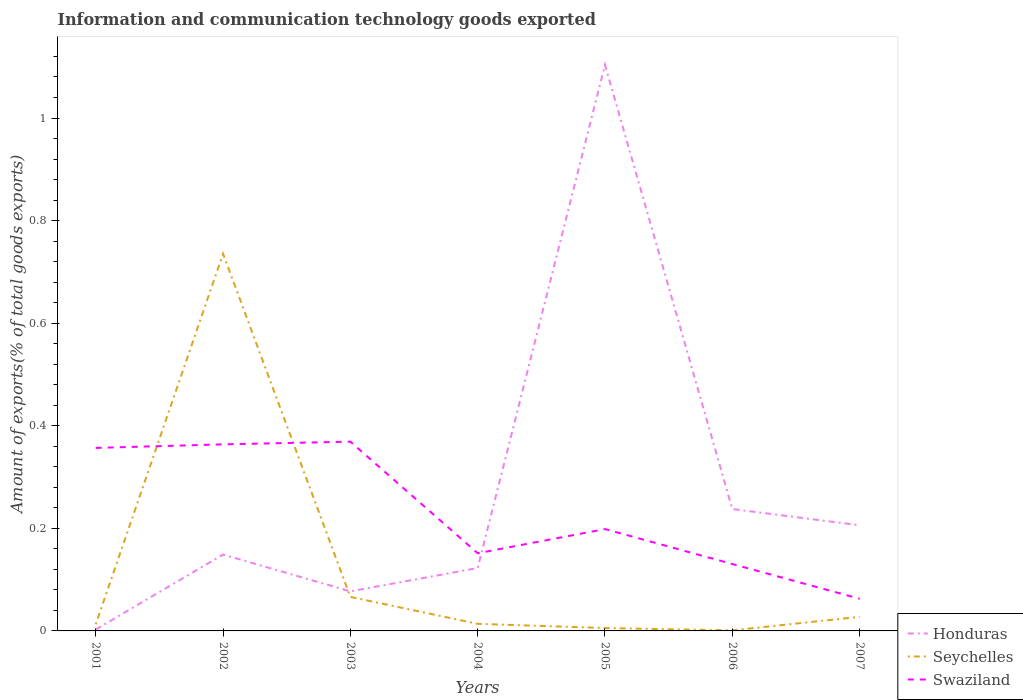How many different coloured lines are there?
Provide a succinct answer. 3. Does the line corresponding to Seychelles intersect with the line corresponding to Swaziland?
Offer a terse response. Yes. Is the number of lines equal to the number of legend labels?
Keep it short and to the point. Yes. Across all years, what is the maximum amount of goods exported in Swaziland?
Provide a succinct answer. 0.06. In which year was the amount of goods exported in Swaziland maximum?
Offer a very short reply. 2007. What is the total amount of goods exported in Swaziland in the graph?
Provide a short and direct response. 0.29. What is the difference between the highest and the second highest amount of goods exported in Seychelles?
Your answer should be compact. 0.73. What is the difference between the highest and the lowest amount of goods exported in Swaziland?
Your response must be concise. 3. Is the amount of goods exported in Honduras strictly greater than the amount of goods exported in Seychelles over the years?
Your answer should be compact. No. How many lines are there?
Provide a succinct answer. 3. How many years are there in the graph?
Ensure brevity in your answer.  7. Does the graph contain any zero values?
Your answer should be very brief. No. Does the graph contain grids?
Offer a very short reply. No. Where does the legend appear in the graph?
Make the answer very short. Bottom right. How are the legend labels stacked?
Your answer should be compact. Vertical. What is the title of the graph?
Your response must be concise. Information and communication technology goods exported. What is the label or title of the X-axis?
Your answer should be compact. Years. What is the label or title of the Y-axis?
Make the answer very short. Amount of exports(% of total goods exports). What is the Amount of exports(% of total goods exports) in Honduras in 2001?
Your answer should be compact. 0. What is the Amount of exports(% of total goods exports) in Seychelles in 2001?
Provide a short and direct response. 0.01. What is the Amount of exports(% of total goods exports) in Swaziland in 2001?
Provide a succinct answer. 0.36. What is the Amount of exports(% of total goods exports) in Honduras in 2002?
Keep it short and to the point. 0.15. What is the Amount of exports(% of total goods exports) in Seychelles in 2002?
Offer a very short reply. 0.74. What is the Amount of exports(% of total goods exports) of Swaziland in 2002?
Make the answer very short. 0.36. What is the Amount of exports(% of total goods exports) of Honduras in 2003?
Your answer should be compact. 0.08. What is the Amount of exports(% of total goods exports) in Seychelles in 2003?
Make the answer very short. 0.07. What is the Amount of exports(% of total goods exports) of Swaziland in 2003?
Your answer should be very brief. 0.37. What is the Amount of exports(% of total goods exports) in Honduras in 2004?
Offer a very short reply. 0.12. What is the Amount of exports(% of total goods exports) of Seychelles in 2004?
Offer a very short reply. 0.01. What is the Amount of exports(% of total goods exports) in Swaziland in 2004?
Your answer should be compact. 0.15. What is the Amount of exports(% of total goods exports) of Honduras in 2005?
Offer a terse response. 1.1. What is the Amount of exports(% of total goods exports) of Seychelles in 2005?
Your answer should be compact. 0.01. What is the Amount of exports(% of total goods exports) of Swaziland in 2005?
Give a very brief answer. 0.2. What is the Amount of exports(% of total goods exports) in Honduras in 2006?
Offer a terse response. 0.24. What is the Amount of exports(% of total goods exports) in Seychelles in 2006?
Make the answer very short. 0. What is the Amount of exports(% of total goods exports) of Swaziland in 2006?
Offer a very short reply. 0.13. What is the Amount of exports(% of total goods exports) of Honduras in 2007?
Offer a terse response. 0.21. What is the Amount of exports(% of total goods exports) of Seychelles in 2007?
Offer a terse response. 0.03. What is the Amount of exports(% of total goods exports) of Swaziland in 2007?
Offer a terse response. 0.06. Across all years, what is the maximum Amount of exports(% of total goods exports) in Honduras?
Keep it short and to the point. 1.1. Across all years, what is the maximum Amount of exports(% of total goods exports) of Seychelles?
Your answer should be compact. 0.74. Across all years, what is the maximum Amount of exports(% of total goods exports) of Swaziland?
Ensure brevity in your answer.  0.37. Across all years, what is the minimum Amount of exports(% of total goods exports) in Honduras?
Ensure brevity in your answer.  0. Across all years, what is the minimum Amount of exports(% of total goods exports) of Seychelles?
Ensure brevity in your answer.  0. Across all years, what is the minimum Amount of exports(% of total goods exports) of Swaziland?
Keep it short and to the point. 0.06. What is the total Amount of exports(% of total goods exports) in Honduras in the graph?
Your answer should be very brief. 1.9. What is the total Amount of exports(% of total goods exports) of Seychelles in the graph?
Your answer should be very brief. 0.86. What is the total Amount of exports(% of total goods exports) of Swaziland in the graph?
Provide a succinct answer. 1.63. What is the difference between the Amount of exports(% of total goods exports) in Honduras in 2001 and that in 2002?
Offer a terse response. -0.15. What is the difference between the Amount of exports(% of total goods exports) in Seychelles in 2001 and that in 2002?
Ensure brevity in your answer.  -0.72. What is the difference between the Amount of exports(% of total goods exports) of Swaziland in 2001 and that in 2002?
Keep it short and to the point. -0.01. What is the difference between the Amount of exports(% of total goods exports) in Honduras in 2001 and that in 2003?
Give a very brief answer. -0.07. What is the difference between the Amount of exports(% of total goods exports) of Seychelles in 2001 and that in 2003?
Ensure brevity in your answer.  -0.05. What is the difference between the Amount of exports(% of total goods exports) in Swaziland in 2001 and that in 2003?
Your answer should be very brief. -0.01. What is the difference between the Amount of exports(% of total goods exports) of Honduras in 2001 and that in 2004?
Make the answer very short. -0.12. What is the difference between the Amount of exports(% of total goods exports) in Seychelles in 2001 and that in 2004?
Offer a terse response. -0. What is the difference between the Amount of exports(% of total goods exports) of Swaziland in 2001 and that in 2004?
Offer a very short reply. 0.21. What is the difference between the Amount of exports(% of total goods exports) in Honduras in 2001 and that in 2005?
Keep it short and to the point. -1.1. What is the difference between the Amount of exports(% of total goods exports) of Seychelles in 2001 and that in 2005?
Your answer should be compact. 0.01. What is the difference between the Amount of exports(% of total goods exports) of Swaziland in 2001 and that in 2005?
Your answer should be very brief. 0.16. What is the difference between the Amount of exports(% of total goods exports) in Honduras in 2001 and that in 2006?
Provide a succinct answer. -0.23. What is the difference between the Amount of exports(% of total goods exports) of Seychelles in 2001 and that in 2006?
Provide a short and direct response. 0.01. What is the difference between the Amount of exports(% of total goods exports) of Swaziland in 2001 and that in 2006?
Your answer should be compact. 0.23. What is the difference between the Amount of exports(% of total goods exports) in Honduras in 2001 and that in 2007?
Offer a very short reply. -0.2. What is the difference between the Amount of exports(% of total goods exports) of Seychelles in 2001 and that in 2007?
Your answer should be compact. -0.01. What is the difference between the Amount of exports(% of total goods exports) of Swaziland in 2001 and that in 2007?
Your answer should be very brief. 0.29. What is the difference between the Amount of exports(% of total goods exports) in Honduras in 2002 and that in 2003?
Offer a terse response. 0.07. What is the difference between the Amount of exports(% of total goods exports) of Seychelles in 2002 and that in 2003?
Provide a succinct answer. 0.67. What is the difference between the Amount of exports(% of total goods exports) in Swaziland in 2002 and that in 2003?
Your answer should be very brief. -0.01. What is the difference between the Amount of exports(% of total goods exports) of Honduras in 2002 and that in 2004?
Give a very brief answer. 0.03. What is the difference between the Amount of exports(% of total goods exports) in Seychelles in 2002 and that in 2004?
Keep it short and to the point. 0.72. What is the difference between the Amount of exports(% of total goods exports) of Swaziland in 2002 and that in 2004?
Offer a terse response. 0.21. What is the difference between the Amount of exports(% of total goods exports) of Honduras in 2002 and that in 2005?
Offer a terse response. -0.95. What is the difference between the Amount of exports(% of total goods exports) in Seychelles in 2002 and that in 2005?
Offer a very short reply. 0.73. What is the difference between the Amount of exports(% of total goods exports) in Swaziland in 2002 and that in 2005?
Keep it short and to the point. 0.17. What is the difference between the Amount of exports(% of total goods exports) of Honduras in 2002 and that in 2006?
Your response must be concise. -0.09. What is the difference between the Amount of exports(% of total goods exports) of Seychelles in 2002 and that in 2006?
Provide a short and direct response. 0.73. What is the difference between the Amount of exports(% of total goods exports) of Swaziland in 2002 and that in 2006?
Offer a very short reply. 0.23. What is the difference between the Amount of exports(% of total goods exports) in Honduras in 2002 and that in 2007?
Offer a very short reply. -0.06. What is the difference between the Amount of exports(% of total goods exports) of Seychelles in 2002 and that in 2007?
Your answer should be very brief. 0.71. What is the difference between the Amount of exports(% of total goods exports) in Swaziland in 2002 and that in 2007?
Offer a very short reply. 0.3. What is the difference between the Amount of exports(% of total goods exports) of Honduras in 2003 and that in 2004?
Ensure brevity in your answer.  -0.05. What is the difference between the Amount of exports(% of total goods exports) in Seychelles in 2003 and that in 2004?
Your answer should be compact. 0.05. What is the difference between the Amount of exports(% of total goods exports) in Swaziland in 2003 and that in 2004?
Offer a very short reply. 0.22. What is the difference between the Amount of exports(% of total goods exports) of Honduras in 2003 and that in 2005?
Offer a terse response. -1.03. What is the difference between the Amount of exports(% of total goods exports) in Seychelles in 2003 and that in 2005?
Ensure brevity in your answer.  0.06. What is the difference between the Amount of exports(% of total goods exports) of Swaziland in 2003 and that in 2005?
Ensure brevity in your answer.  0.17. What is the difference between the Amount of exports(% of total goods exports) of Honduras in 2003 and that in 2006?
Offer a terse response. -0.16. What is the difference between the Amount of exports(% of total goods exports) in Seychelles in 2003 and that in 2006?
Offer a very short reply. 0.07. What is the difference between the Amount of exports(% of total goods exports) of Swaziland in 2003 and that in 2006?
Provide a succinct answer. 0.24. What is the difference between the Amount of exports(% of total goods exports) of Honduras in 2003 and that in 2007?
Your answer should be compact. -0.13. What is the difference between the Amount of exports(% of total goods exports) in Seychelles in 2003 and that in 2007?
Ensure brevity in your answer.  0.04. What is the difference between the Amount of exports(% of total goods exports) in Swaziland in 2003 and that in 2007?
Offer a terse response. 0.31. What is the difference between the Amount of exports(% of total goods exports) of Honduras in 2004 and that in 2005?
Your answer should be very brief. -0.98. What is the difference between the Amount of exports(% of total goods exports) of Seychelles in 2004 and that in 2005?
Ensure brevity in your answer.  0.01. What is the difference between the Amount of exports(% of total goods exports) in Swaziland in 2004 and that in 2005?
Make the answer very short. -0.05. What is the difference between the Amount of exports(% of total goods exports) of Honduras in 2004 and that in 2006?
Your answer should be compact. -0.12. What is the difference between the Amount of exports(% of total goods exports) of Seychelles in 2004 and that in 2006?
Make the answer very short. 0.01. What is the difference between the Amount of exports(% of total goods exports) in Swaziland in 2004 and that in 2006?
Your response must be concise. 0.02. What is the difference between the Amount of exports(% of total goods exports) of Honduras in 2004 and that in 2007?
Provide a succinct answer. -0.08. What is the difference between the Amount of exports(% of total goods exports) of Seychelles in 2004 and that in 2007?
Keep it short and to the point. -0.01. What is the difference between the Amount of exports(% of total goods exports) in Swaziland in 2004 and that in 2007?
Keep it short and to the point. 0.09. What is the difference between the Amount of exports(% of total goods exports) in Honduras in 2005 and that in 2006?
Your response must be concise. 0.87. What is the difference between the Amount of exports(% of total goods exports) of Seychelles in 2005 and that in 2006?
Offer a terse response. 0. What is the difference between the Amount of exports(% of total goods exports) of Swaziland in 2005 and that in 2006?
Your response must be concise. 0.07. What is the difference between the Amount of exports(% of total goods exports) in Honduras in 2005 and that in 2007?
Offer a very short reply. 0.9. What is the difference between the Amount of exports(% of total goods exports) of Seychelles in 2005 and that in 2007?
Your response must be concise. -0.02. What is the difference between the Amount of exports(% of total goods exports) of Swaziland in 2005 and that in 2007?
Provide a short and direct response. 0.14. What is the difference between the Amount of exports(% of total goods exports) of Honduras in 2006 and that in 2007?
Provide a succinct answer. 0.03. What is the difference between the Amount of exports(% of total goods exports) in Seychelles in 2006 and that in 2007?
Your answer should be compact. -0.03. What is the difference between the Amount of exports(% of total goods exports) in Swaziland in 2006 and that in 2007?
Your response must be concise. 0.07. What is the difference between the Amount of exports(% of total goods exports) of Honduras in 2001 and the Amount of exports(% of total goods exports) of Seychelles in 2002?
Your answer should be compact. -0.73. What is the difference between the Amount of exports(% of total goods exports) of Honduras in 2001 and the Amount of exports(% of total goods exports) of Swaziland in 2002?
Make the answer very short. -0.36. What is the difference between the Amount of exports(% of total goods exports) in Seychelles in 2001 and the Amount of exports(% of total goods exports) in Swaziland in 2002?
Keep it short and to the point. -0.35. What is the difference between the Amount of exports(% of total goods exports) of Honduras in 2001 and the Amount of exports(% of total goods exports) of Seychelles in 2003?
Provide a short and direct response. -0.06. What is the difference between the Amount of exports(% of total goods exports) in Honduras in 2001 and the Amount of exports(% of total goods exports) in Swaziland in 2003?
Your response must be concise. -0.37. What is the difference between the Amount of exports(% of total goods exports) of Seychelles in 2001 and the Amount of exports(% of total goods exports) of Swaziland in 2003?
Provide a short and direct response. -0.36. What is the difference between the Amount of exports(% of total goods exports) in Honduras in 2001 and the Amount of exports(% of total goods exports) in Seychelles in 2004?
Provide a succinct answer. -0.01. What is the difference between the Amount of exports(% of total goods exports) of Honduras in 2001 and the Amount of exports(% of total goods exports) of Swaziland in 2004?
Make the answer very short. -0.15. What is the difference between the Amount of exports(% of total goods exports) in Seychelles in 2001 and the Amount of exports(% of total goods exports) in Swaziland in 2004?
Make the answer very short. -0.14. What is the difference between the Amount of exports(% of total goods exports) in Honduras in 2001 and the Amount of exports(% of total goods exports) in Seychelles in 2005?
Your response must be concise. -0. What is the difference between the Amount of exports(% of total goods exports) in Honduras in 2001 and the Amount of exports(% of total goods exports) in Swaziland in 2005?
Make the answer very short. -0.2. What is the difference between the Amount of exports(% of total goods exports) of Seychelles in 2001 and the Amount of exports(% of total goods exports) of Swaziland in 2005?
Your answer should be very brief. -0.19. What is the difference between the Amount of exports(% of total goods exports) of Honduras in 2001 and the Amount of exports(% of total goods exports) of Seychelles in 2006?
Provide a succinct answer. 0. What is the difference between the Amount of exports(% of total goods exports) in Honduras in 2001 and the Amount of exports(% of total goods exports) in Swaziland in 2006?
Provide a succinct answer. -0.13. What is the difference between the Amount of exports(% of total goods exports) in Seychelles in 2001 and the Amount of exports(% of total goods exports) in Swaziland in 2006?
Make the answer very short. -0.12. What is the difference between the Amount of exports(% of total goods exports) in Honduras in 2001 and the Amount of exports(% of total goods exports) in Seychelles in 2007?
Make the answer very short. -0.02. What is the difference between the Amount of exports(% of total goods exports) in Honduras in 2001 and the Amount of exports(% of total goods exports) in Swaziland in 2007?
Provide a short and direct response. -0.06. What is the difference between the Amount of exports(% of total goods exports) of Seychelles in 2001 and the Amount of exports(% of total goods exports) of Swaziland in 2007?
Offer a very short reply. -0.05. What is the difference between the Amount of exports(% of total goods exports) in Honduras in 2002 and the Amount of exports(% of total goods exports) in Seychelles in 2003?
Ensure brevity in your answer.  0.08. What is the difference between the Amount of exports(% of total goods exports) of Honduras in 2002 and the Amount of exports(% of total goods exports) of Swaziland in 2003?
Your answer should be compact. -0.22. What is the difference between the Amount of exports(% of total goods exports) in Seychelles in 2002 and the Amount of exports(% of total goods exports) in Swaziland in 2003?
Make the answer very short. 0.37. What is the difference between the Amount of exports(% of total goods exports) of Honduras in 2002 and the Amount of exports(% of total goods exports) of Seychelles in 2004?
Your response must be concise. 0.14. What is the difference between the Amount of exports(% of total goods exports) of Honduras in 2002 and the Amount of exports(% of total goods exports) of Swaziland in 2004?
Your response must be concise. -0. What is the difference between the Amount of exports(% of total goods exports) in Seychelles in 2002 and the Amount of exports(% of total goods exports) in Swaziland in 2004?
Your answer should be very brief. 0.58. What is the difference between the Amount of exports(% of total goods exports) of Honduras in 2002 and the Amount of exports(% of total goods exports) of Seychelles in 2005?
Your answer should be very brief. 0.14. What is the difference between the Amount of exports(% of total goods exports) in Honduras in 2002 and the Amount of exports(% of total goods exports) in Swaziland in 2005?
Your response must be concise. -0.05. What is the difference between the Amount of exports(% of total goods exports) in Seychelles in 2002 and the Amount of exports(% of total goods exports) in Swaziland in 2005?
Keep it short and to the point. 0.54. What is the difference between the Amount of exports(% of total goods exports) of Honduras in 2002 and the Amount of exports(% of total goods exports) of Seychelles in 2006?
Your answer should be compact. 0.15. What is the difference between the Amount of exports(% of total goods exports) in Honduras in 2002 and the Amount of exports(% of total goods exports) in Swaziland in 2006?
Provide a short and direct response. 0.02. What is the difference between the Amount of exports(% of total goods exports) of Seychelles in 2002 and the Amount of exports(% of total goods exports) of Swaziland in 2006?
Your answer should be compact. 0.6. What is the difference between the Amount of exports(% of total goods exports) in Honduras in 2002 and the Amount of exports(% of total goods exports) in Seychelles in 2007?
Your response must be concise. 0.12. What is the difference between the Amount of exports(% of total goods exports) in Honduras in 2002 and the Amount of exports(% of total goods exports) in Swaziland in 2007?
Provide a succinct answer. 0.09. What is the difference between the Amount of exports(% of total goods exports) of Seychelles in 2002 and the Amount of exports(% of total goods exports) of Swaziland in 2007?
Give a very brief answer. 0.67. What is the difference between the Amount of exports(% of total goods exports) in Honduras in 2003 and the Amount of exports(% of total goods exports) in Seychelles in 2004?
Your answer should be compact. 0.06. What is the difference between the Amount of exports(% of total goods exports) in Honduras in 2003 and the Amount of exports(% of total goods exports) in Swaziland in 2004?
Your answer should be compact. -0.07. What is the difference between the Amount of exports(% of total goods exports) of Seychelles in 2003 and the Amount of exports(% of total goods exports) of Swaziland in 2004?
Offer a very short reply. -0.09. What is the difference between the Amount of exports(% of total goods exports) in Honduras in 2003 and the Amount of exports(% of total goods exports) in Seychelles in 2005?
Your response must be concise. 0.07. What is the difference between the Amount of exports(% of total goods exports) of Honduras in 2003 and the Amount of exports(% of total goods exports) of Swaziland in 2005?
Keep it short and to the point. -0.12. What is the difference between the Amount of exports(% of total goods exports) in Seychelles in 2003 and the Amount of exports(% of total goods exports) in Swaziland in 2005?
Your answer should be compact. -0.13. What is the difference between the Amount of exports(% of total goods exports) in Honduras in 2003 and the Amount of exports(% of total goods exports) in Seychelles in 2006?
Provide a succinct answer. 0.08. What is the difference between the Amount of exports(% of total goods exports) in Honduras in 2003 and the Amount of exports(% of total goods exports) in Swaziland in 2006?
Offer a very short reply. -0.05. What is the difference between the Amount of exports(% of total goods exports) in Seychelles in 2003 and the Amount of exports(% of total goods exports) in Swaziland in 2006?
Ensure brevity in your answer.  -0.06. What is the difference between the Amount of exports(% of total goods exports) of Honduras in 2003 and the Amount of exports(% of total goods exports) of Seychelles in 2007?
Provide a short and direct response. 0.05. What is the difference between the Amount of exports(% of total goods exports) of Honduras in 2003 and the Amount of exports(% of total goods exports) of Swaziland in 2007?
Provide a short and direct response. 0.01. What is the difference between the Amount of exports(% of total goods exports) of Seychelles in 2003 and the Amount of exports(% of total goods exports) of Swaziland in 2007?
Your answer should be very brief. 0. What is the difference between the Amount of exports(% of total goods exports) of Honduras in 2004 and the Amount of exports(% of total goods exports) of Seychelles in 2005?
Give a very brief answer. 0.12. What is the difference between the Amount of exports(% of total goods exports) in Honduras in 2004 and the Amount of exports(% of total goods exports) in Swaziland in 2005?
Offer a terse response. -0.08. What is the difference between the Amount of exports(% of total goods exports) of Seychelles in 2004 and the Amount of exports(% of total goods exports) of Swaziland in 2005?
Your response must be concise. -0.18. What is the difference between the Amount of exports(% of total goods exports) in Honduras in 2004 and the Amount of exports(% of total goods exports) in Seychelles in 2006?
Offer a terse response. 0.12. What is the difference between the Amount of exports(% of total goods exports) of Honduras in 2004 and the Amount of exports(% of total goods exports) of Swaziland in 2006?
Your response must be concise. -0.01. What is the difference between the Amount of exports(% of total goods exports) in Seychelles in 2004 and the Amount of exports(% of total goods exports) in Swaziland in 2006?
Your response must be concise. -0.12. What is the difference between the Amount of exports(% of total goods exports) of Honduras in 2004 and the Amount of exports(% of total goods exports) of Seychelles in 2007?
Your response must be concise. 0.1. What is the difference between the Amount of exports(% of total goods exports) of Honduras in 2004 and the Amount of exports(% of total goods exports) of Swaziland in 2007?
Keep it short and to the point. 0.06. What is the difference between the Amount of exports(% of total goods exports) in Seychelles in 2004 and the Amount of exports(% of total goods exports) in Swaziland in 2007?
Ensure brevity in your answer.  -0.05. What is the difference between the Amount of exports(% of total goods exports) in Honduras in 2005 and the Amount of exports(% of total goods exports) in Seychelles in 2006?
Your response must be concise. 1.1. What is the difference between the Amount of exports(% of total goods exports) of Honduras in 2005 and the Amount of exports(% of total goods exports) of Swaziland in 2006?
Provide a succinct answer. 0.97. What is the difference between the Amount of exports(% of total goods exports) of Seychelles in 2005 and the Amount of exports(% of total goods exports) of Swaziland in 2006?
Your answer should be compact. -0.12. What is the difference between the Amount of exports(% of total goods exports) of Honduras in 2005 and the Amount of exports(% of total goods exports) of Seychelles in 2007?
Offer a very short reply. 1.08. What is the difference between the Amount of exports(% of total goods exports) of Honduras in 2005 and the Amount of exports(% of total goods exports) of Swaziland in 2007?
Make the answer very short. 1.04. What is the difference between the Amount of exports(% of total goods exports) in Seychelles in 2005 and the Amount of exports(% of total goods exports) in Swaziland in 2007?
Give a very brief answer. -0.06. What is the difference between the Amount of exports(% of total goods exports) in Honduras in 2006 and the Amount of exports(% of total goods exports) in Seychelles in 2007?
Provide a succinct answer. 0.21. What is the difference between the Amount of exports(% of total goods exports) in Honduras in 2006 and the Amount of exports(% of total goods exports) in Swaziland in 2007?
Provide a succinct answer. 0.17. What is the difference between the Amount of exports(% of total goods exports) in Seychelles in 2006 and the Amount of exports(% of total goods exports) in Swaziland in 2007?
Your response must be concise. -0.06. What is the average Amount of exports(% of total goods exports) of Honduras per year?
Offer a terse response. 0.27. What is the average Amount of exports(% of total goods exports) in Seychelles per year?
Give a very brief answer. 0.12. What is the average Amount of exports(% of total goods exports) of Swaziland per year?
Your response must be concise. 0.23. In the year 2001, what is the difference between the Amount of exports(% of total goods exports) of Honduras and Amount of exports(% of total goods exports) of Seychelles?
Make the answer very short. -0.01. In the year 2001, what is the difference between the Amount of exports(% of total goods exports) in Honduras and Amount of exports(% of total goods exports) in Swaziland?
Offer a terse response. -0.35. In the year 2001, what is the difference between the Amount of exports(% of total goods exports) in Seychelles and Amount of exports(% of total goods exports) in Swaziland?
Give a very brief answer. -0.34. In the year 2002, what is the difference between the Amount of exports(% of total goods exports) in Honduras and Amount of exports(% of total goods exports) in Seychelles?
Make the answer very short. -0.59. In the year 2002, what is the difference between the Amount of exports(% of total goods exports) of Honduras and Amount of exports(% of total goods exports) of Swaziland?
Make the answer very short. -0.21. In the year 2002, what is the difference between the Amount of exports(% of total goods exports) of Seychelles and Amount of exports(% of total goods exports) of Swaziland?
Ensure brevity in your answer.  0.37. In the year 2003, what is the difference between the Amount of exports(% of total goods exports) in Honduras and Amount of exports(% of total goods exports) in Seychelles?
Ensure brevity in your answer.  0.01. In the year 2003, what is the difference between the Amount of exports(% of total goods exports) in Honduras and Amount of exports(% of total goods exports) in Swaziland?
Provide a short and direct response. -0.29. In the year 2003, what is the difference between the Amount of exports(% of total goods exports) of Seychelles and Amount of exports(% of total goods exports) of Swaziland?
Your answer should be compact. -0.3. In the year 2004, what is the difference between the Amount of exports(% of total goods exports) of Honduras and Amount of exports(% of total goods exports) of Seychelles?
Your answer should be compact. 0.11. In the year 2004, what is the difference between the Amount of exports(% of total goods exports) of Honduras and Amount of exports(% of total goods exports) of Swaziland?
Ensure brevity in your answer.  -0.03. In the year 2004, what is the difference between the Amount of exports(% of total goods exports) in Seychelles and Amount of exports(% of total goods exports) in Swaziland?
Your answer should be very brief. -0.14. In the year 2005, what is the difference between the Amount of exports(% of total goods exports) of Honduras and Amount of exports(% of total goods exports) of Seychelles?
Offer a very short reply. 1.1. In the year 2005, what is the difference between the Amount of exports(% of total goods exports) in Honduras and Amount of exports(% of total goods exports) in Swaziland?
Your answer should be compact. 0.91. In the year 2005, what is the difference between the Amount of exports(% of total goods exports) in Seychelles and Amount of exports(% of total goods exports) in Swaziland?
Offer a very short reply. -0.19. In the year 2006, what is the difference between the Amount of exports(% of total goods exports) in Honduras and Amount of exports(% of total goods exports) in Seychelles?
Keep it short and to the point. 0.24. In the year 2006, what is the difference between the Amount of exports(% of total goods exports) in Honduras and Amount of exports(% of total goods exports) in Swaziland?
Ensure brevity in your answer.  0.11. In the year 2006, what is the difference between the Amount of exports(% of total goods exports) in Seychelles and Amount of exports(% of total goods exports) in Swaziland?
Ensure brevity in your answer.  -0.13. In the year 2007, what is the difference between the Amount of exports(% of total goods exports) in Honduras and Amount of exports(% of total goods exports) in Seychelles?
Give a very brief answer. 0.18. In the year 2007, what is the difference between the Amount of exports(% of total goods exports) of Honduras and Amount of exports(% of total goods exports) of Swaziland?
Offer a very short reply. 0.14. In the year 2007, what is the difference between the Amount of exports(% of total goods exports) in Seychelles and Amount of exports(% of total goods exports) in Swaziland?
Your answer should be very brief. -0.04. What is the ratio of the Amount of exports(% of total goods exports) in Honduras in 2001 to that in 2002?
Your answer should be very brief. 0.02. What is the ratio of the Amount of exports(% of total goods exports) in Seychelles in 2001 to that in 2002?
Give a very brief answer. 0.02. What is the ratio of the Amount of exports(% of total goods exports) of Swaziland in 2001 to that in 2002?
Offer a very short reply. 0.98. What is the ratio of the Amount of exports(% of total goods exports) in Honduras in 2001 to that in 2003?
Keep it short and to the point. 0.04. What is the ratio of the Amount of exports(% of total goods exports) in Seychelles in 2001 to that in 2003?
Give a very brief answer. 0.19. What is the ratio of the Amount of exports(% of total goods exports) of Swaziland in 2001 to that in 2003?
Provide a short and direct response. 0.97. What is the ratio of the Amount of exports(% of total goods exports) in Honduras in 2001 to that in 2004?
Give a very brief answer. 0.02. What is the ratio of the Amount of exports(% of total goods exports) of Seychelles in 2001 to that in 2004?
Give a very brief answer. 0.94. What is the ratio of the Amount of exports(% of total goods exports) in Swaziland in 2001 to that in 2004?
Give a very brief answer. 2.36. What is the ratio of the Amount of exports(% of total goods exports) of Honduras in 2001 to that in 2005?
Your answer should be very brief. 0. What is the ratio of the Amount of exports(% of total goods exports) in Seychelles in 2001 to that in 2005?
Offer a terse response. 2.31. What is the ratio of the Amount of exports(% of total goods exports) of Swaziland in 2001 to that in 2005?
Provide a short and direct response. 1.8. What is the ratio of the Amount of exports(% of total goods exports) in Honduras in 2001 to that in 2006?
Keep it short and to the point. 0.01. What is the ratio of the Amount of exports(% of total goods exports) of Seychelles in 2001 to that in 2006?
Provide a short and direct response. 11.46. What is the ratio of the Amount of exports(% of total goods exports) in Swaziland in 2001 to that in 2006?
Provide a short and direct response. 2.74. What is the ratio of the Amount of exports(% of total goods exports) of Honduras in 2001 to that in 2007?
Your response must be concise. 0.01. What is the ratio of the Amount of exports(% of total goods exports) in Seychelles in 2001 to that in 2007?
Make the answer very short. 0.47. What is the ratio of the Amount of exports(% of total goods exports) of Swaziland in 2001 to that in 2007?
Your answer should be very brief. 5.69. What is the ratio of the Amount of exports(% of total goods exports) of Honduras in 2002 to that in 2003?
Offer a very short reply. 1.93. What is the ratio of the Amount of exports(% of total goods exports) in Seychelles in 2002 to that in 2003?
Offer a terse response. 11.08. What is the ratio of the Amount of exports(% of total goods exports) of Swaziland in 2002 to that in 2003?
Your answer should be very brief. 0.99. What is the ratio of the Amount of exports(% of total goods exports) of Honduras in 2002 to that in 2004?
Provide a short and direct response. 1.21. What is the ratio of the Amount of exports(% of total goods exports) of Seychelles in 2002 to that in 2004?
Your answer should be very brief. 53.2. What is the ratio of the Amount of exports(% of total goods exports) in Swaziland in 2002 to that in 2004?
Offer a very short reply. 2.4. What is the ratio of the Amount of exports(% of total goods exports) in Honduras in 2002 to that in 2005?
Your answer should be very brief. 0.13. What is the ratio of the Amount of exports(% of total goods exports) in Seychelles in 2002 to that in 2005?
Offer a very short reply. 131.22. What is the ratio of the Amount of exports(% of total goods exports) in Swaziland in 2002 to that in 2005?
Provide a short and direct response. 1.83. What is the ratio of the Amount of exports(% of total goods exports) of Honduras in 2002 to that in 2006?
Give a very brief answer. 0.63. What is the ratio of the Amount of exports(% of total goods exports) in Seychelles in 2002 to that in 2006?
Offer a very short reply. 652.15. What is the ratio of the Amount of exports(% of total goods exports) of Swaziland in 2002 to that in 2006?
Your answer should be very brief. 2.79. What is the ratio of the Amount of exports(% of total goods exports) of Honduras in 2002 to that in 2007?
Your response must be concise. 0.72. What is the ratio of the Amount of exports(% of total goods exports) in Seychelles in 2002 to that in 2007?
Your response must be concise. 26.71. What is the ratio of the Amount of exports(% of total goods exports) in Swaziland in 2002 to that in 2007?
Your answer should be compact. 5.8. What is the ratio of the Amount of exports(% of total goods exports) in Honduras in 2003 to that in 2004?
Provide a succinct answer. 0.63. What is the ratio of the Amount of exports(% of total goods exports) in Seychelles in 2003 to that in 2004?
Offer a very short reply. 4.8. What is the ratio of the Amount of exports(% of total goods exports) in Swaziland in 2003 to that in 2004?
Your answer should be compact. 2.44. What is the ratio of the Amount of exports(% of total goods exports) in Honduras in 2003 to that in 2005?
Offer a terse response. 0.07. What is the ratio of the Amount of exports(% of total goods exports) in Seychelles in 2003 to that in 2005?
Provide a short and direct response. 11.84. What is the ratio of the Amount of exports(% of total goods exports) of Swaziland in 2003 to that in 2005?
Give a very brief answer. 1.86. What is the ratio of the Amount of exports(% of total goods exports) in Honduras in 2003 to that in 2006?
Offer a terse response. 0.32. What is the ratio of the Amount of exports(% of total goods exports) in Seychelles in 2003 to that in 2006?
Keep it short and to the point. 58.83. What is the ratio of the Amount of exports(% of total goods exports) of Swaziland in 2003 to that in 2006?
Ensure brevity in your answer.  2.83. What is the ratio of the Amount of exports(% of total goods exports) of Honduras in 2003 to that in 2007?
Your response must be concise. 0.37. What is the ratio of the Amount of exports(% of total goods exports) in Seychelles in 2003 to that in 2007?
Your answer should be very brief. 2.41. What is the ratio of the Amount of exports(% of total goods exports) in Swaziland in 2003 to that in 2007?
Make the answer very short. 5.88. What is the ratio of the Amount of exports(% of total goods exports) in Seychelles in 2004 to that in 2005?
Your response must be concise. 2.47. What is the ratio of the Amount of exports(% of total goods exports) in Swaziland in 2004 to that in 2005?
Give a very brief answer. 0.76. What is the ratio of the Amount of exports(% of total goods exports) in Honduras in 2004 to that in 2006?
Make the answer very short. 0.52. What is the ratio of the Amount of exports(% of total goods exports) in Seychelles in 2004 to that in 2006?
Offer a terse response. 12.26. What is the ratio of the Amount of exports(% of total goods exports) of Swaziland in 2004 to that in 2006?
Keep it short and to the point. 1.16. What is the ratio of the Amount of exports(% of total goods exports) of Honduras in 2004 to that in 2007?
Your answer should be very brief. 0.6. What is the ratio of the Amount of exports(% of total goods exports) of Seychelles in 2004 to that in 2007?
Your answer should be very brief. 0.5. What is the ratio of the Amount of exports(% of total goods exports) in Swaziland in 2004 to that in 2007?
Your answer should be compact. 2.42. What is the ratio of the Amount of exports(% of total goods exports) in Honduras in 2005 to that in 2006?
Provide a succinct answer. 4.64. What is the ratio of the Amount of exports(% of total goods exports) of Seychelles in 2005 to that in 2006?
Your answer should be very brief. 4.97. What is the ratio of the Amount of exports(% of total goods exports) of Swaziland in 2005 to that in 2006?
Ensure brevity in your answer.  1.52. What is the ratio of the Amount of exports(% of total goods exports) in Honduras in 2005 to that in 2007?
Offer a very short reply. 5.36. What is the ratio of the Amount of exports(% of total goods exports) in Seychelles in 2005 to that in 2007?
Your answer should be compact. 0.2. What is the ratio of the Amount of exports(% of total goods exports) in Swaziland in 2005 to that in 2007?
Make the answer very short. 3.17. What is the ratio of the Amount of exports(% of total goods exports) in Honduras in 2006 to that in 2007?
Keep it short and to the point. 1.15. What is the ratio of the Amount of exports(% of total goods exports) of Seychelles in 2006 to that in 2007?
Keep it short and to the point. 0.04. What is the ratio of the Amount of exports(% of total goods exports) of Swaziland in 2006 to that in 2007?
Give a very brief answer. 2.08. What is the difference between the highest and the second highest Amount of exports(% of total goods exports) in Honduras?
Keep it short and to the point. 0.87. What is the difference between the highest and the second highest Amount of exports(% of total goods exports) of Seychelles?
Your response must be concise. 0.67. What is the difference between the highest and the second highest Amount of exports(% of total goods exports) of Swaziland?
Offer a terse response. 0.01. What is the difference between the highest and the lowest Amount of exports(% of total goods exports) in Honduras?
Your answer should be very brief. 1.1. What is the difference between the highest and the lowest Amount of exports(% of total goods exports) of Seychelles?
Your answer should be very brief. 0.73. What is the difference between the highest and the lowest Amount of exports(% of total goods exports) in Swaziland?
Keep it short and to the point. 0.31. 